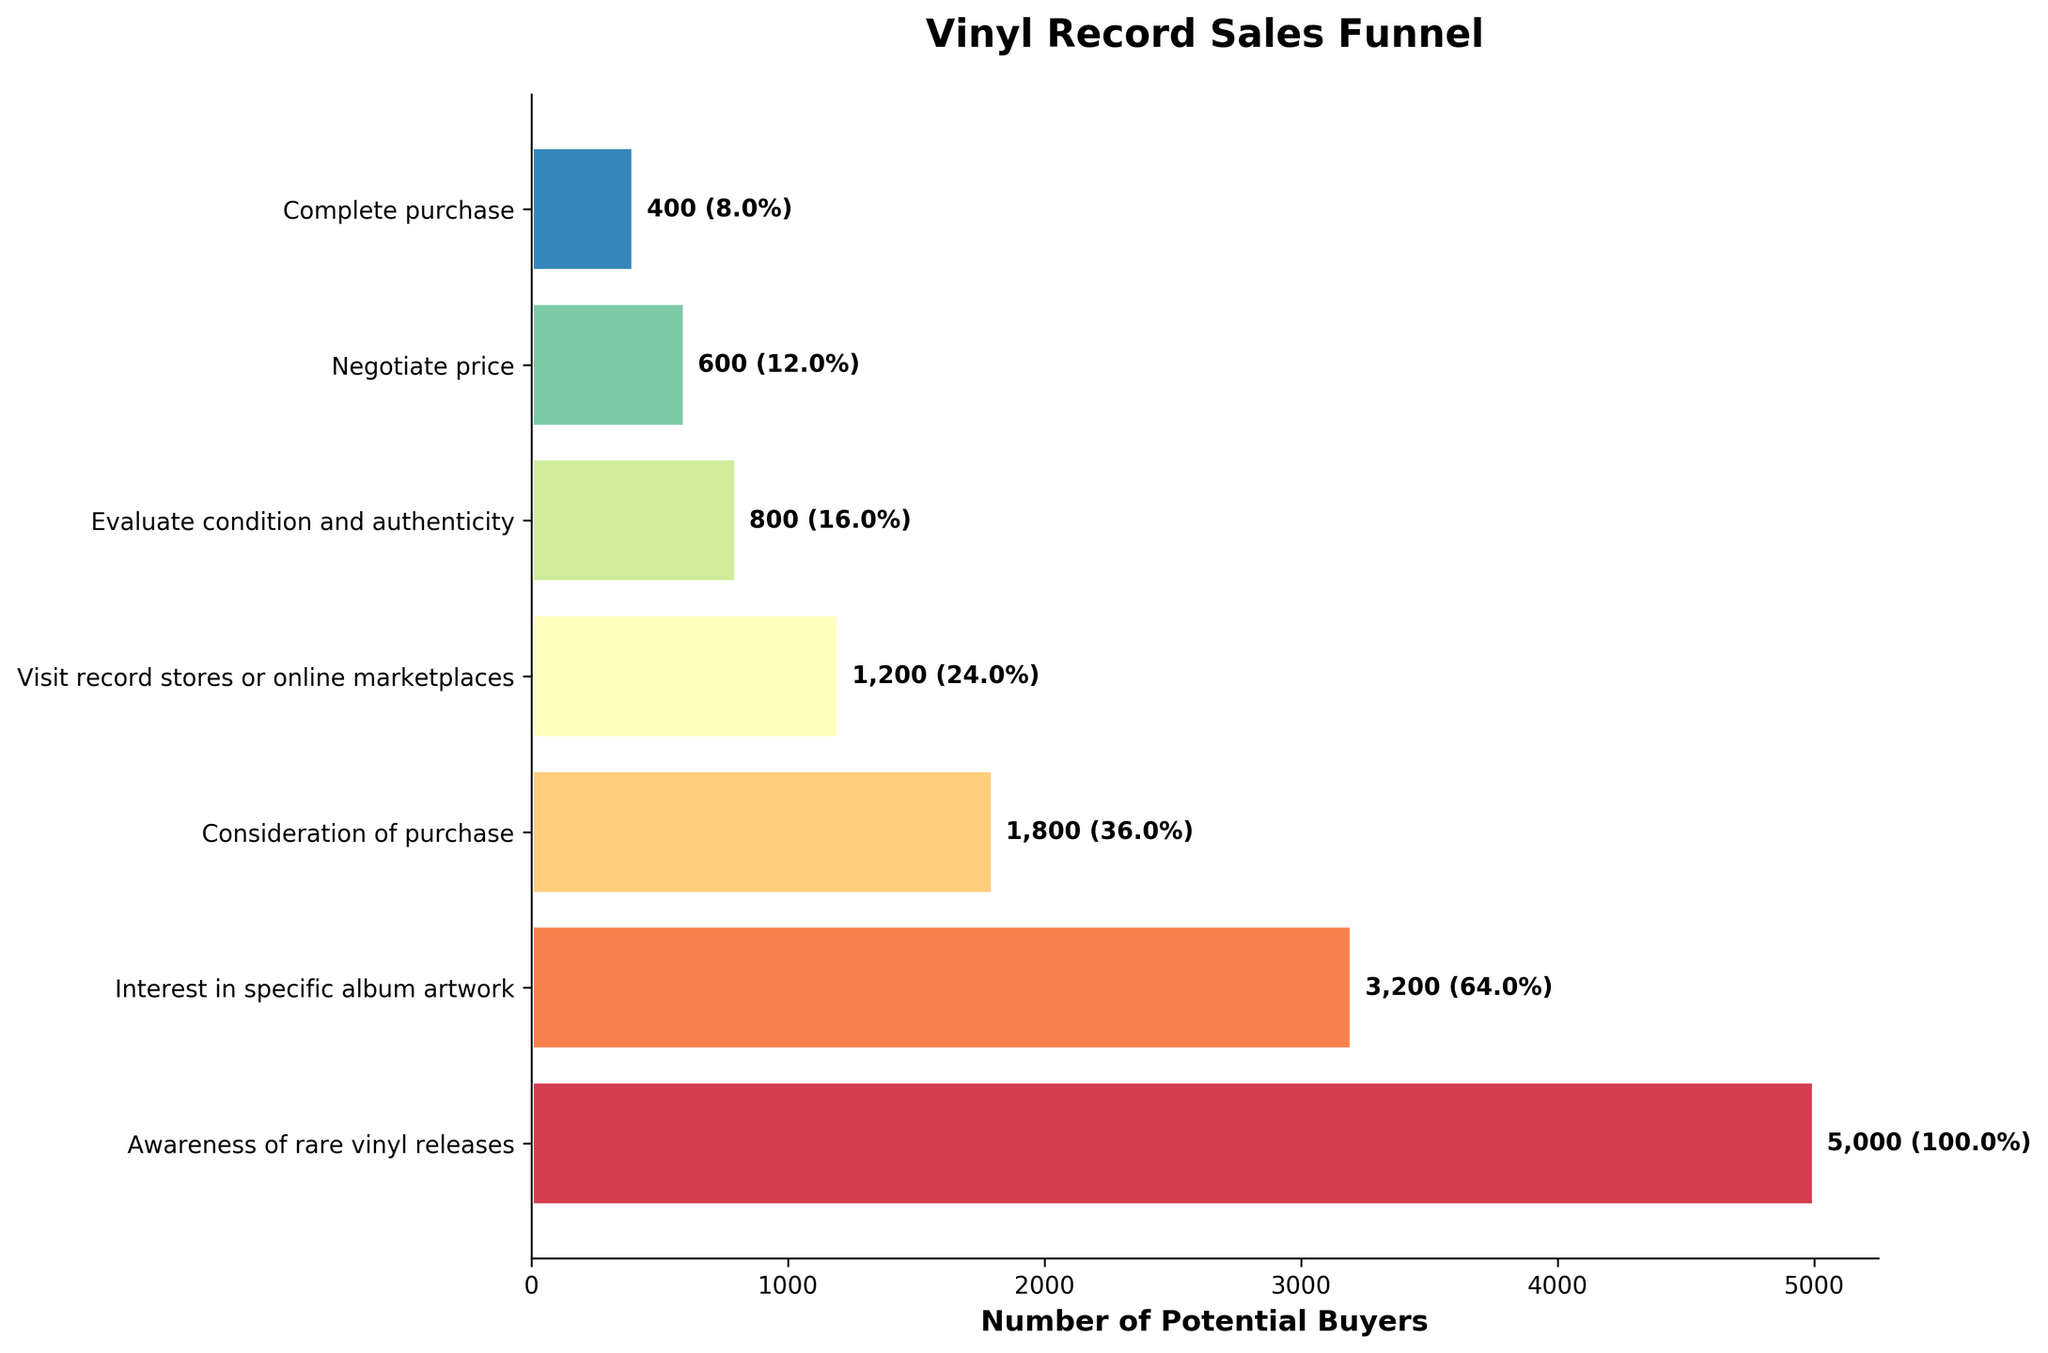How many people were aware of rare vinyl releases? The number of people at the "Awareness of rare vinyl releases" stage can be read directly from the figure.
Answer: 5000 What's the ratio of people who completed a purchase to those who visited record stores or online marketplaces? The number of people who completed a purchase is 400, and the number who visited record stores or online marketplaces is 1200. The ratio is 400/1200 = 1:3.
Answer: 1:3 Which stage sees the biggest drop in numbers? By looking at the figure, compare the differences between consecutive stages: 5000 to 3200 (1800), 3200 to 1800 (1400), 1800 to 1200 (600), 1200 to 800 (400), 800 to 600 (200), 600 to 400 (200). The biggest drop is from Awareness (5000) to Interest (3200), which is 1800.
Answer: From Awareness to Interest What percentage of people who were interested in specific album artwork ended up completing a purchase? The number of people interested in specific album artwork is 3200, and those who completed a purchase are 400. The percentage is (400/3200) * 100 = 12.5%.
Answer: 12.5% In terms of absolute numbers, how many more people were interested in specific album artwork compared to those considering a purchase? The number of people interested in specific album artwork is 3200, and those considering a purchase is 1800. The difference is 3200 - 1800 = 1400.
Answer: 1400 Which stages have checks for condition and authenticity, and how many people are at this stage? The stage for evaluating condition and authenticity can be identified by its label. The number of people at this stage is 800.
Answer: 800 Among those who visited record stores or online marketplaces, what fraction proceeded to negotiate the price? The number who visited record stores or online marketplaces is 1200, and those who negotiated the price is 600. The fraction is 600/1200 = 1/2 or 0.5.
Answer: 0.5 How does the number of people interested in specific album artwork compare to those aware of rare vinyl releases, in terms of percentage? The number interested in specific album artwork is 3200, and those aware of rare vinyl releases is 5000. The percentage is (3200/5000) * 100 = 64%.
Answer: 64% What is the title of the figure? The title of the figure can be read directly from the top of the plot.
Answer: Vinyl Record Sales Funnel How many potential buyers are lost between the interest stage and the consideration stage? The number of people at the interest stage is 3200 and at the consideration stage is 1800. The difference is 3200 - 1800 = 1400.
Answer: 1400 